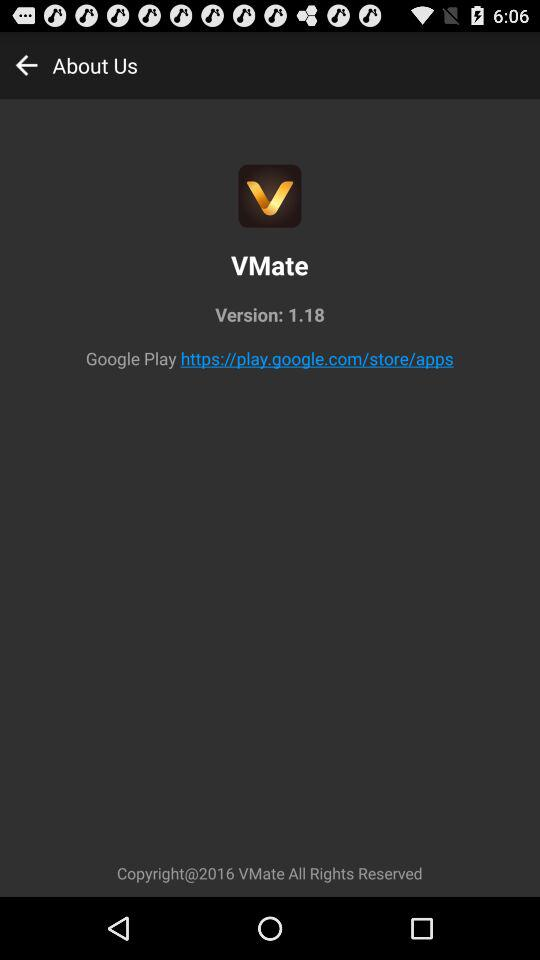What is the application name? The application name is "VMate". 